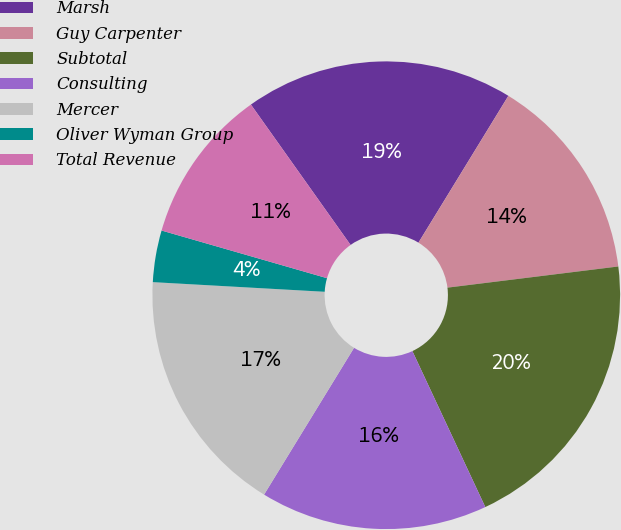<chart> <loc_0><loc_0><loc_500><loc_500><pie_chart><fcel>Marsh<fcel>Guy Carpenter<fcel>Subtotal<fcel>Consulting<fcel>Mercer<fcel>Oliver Wyman Group<fcel>Total Revenue<nl><fcel>18.57%<fcel>14.29%<fcel>20.0%<fcel>15.71%<fcel>17.14%<fcel>3.57%<fcel>10.71%<nl></chart> 